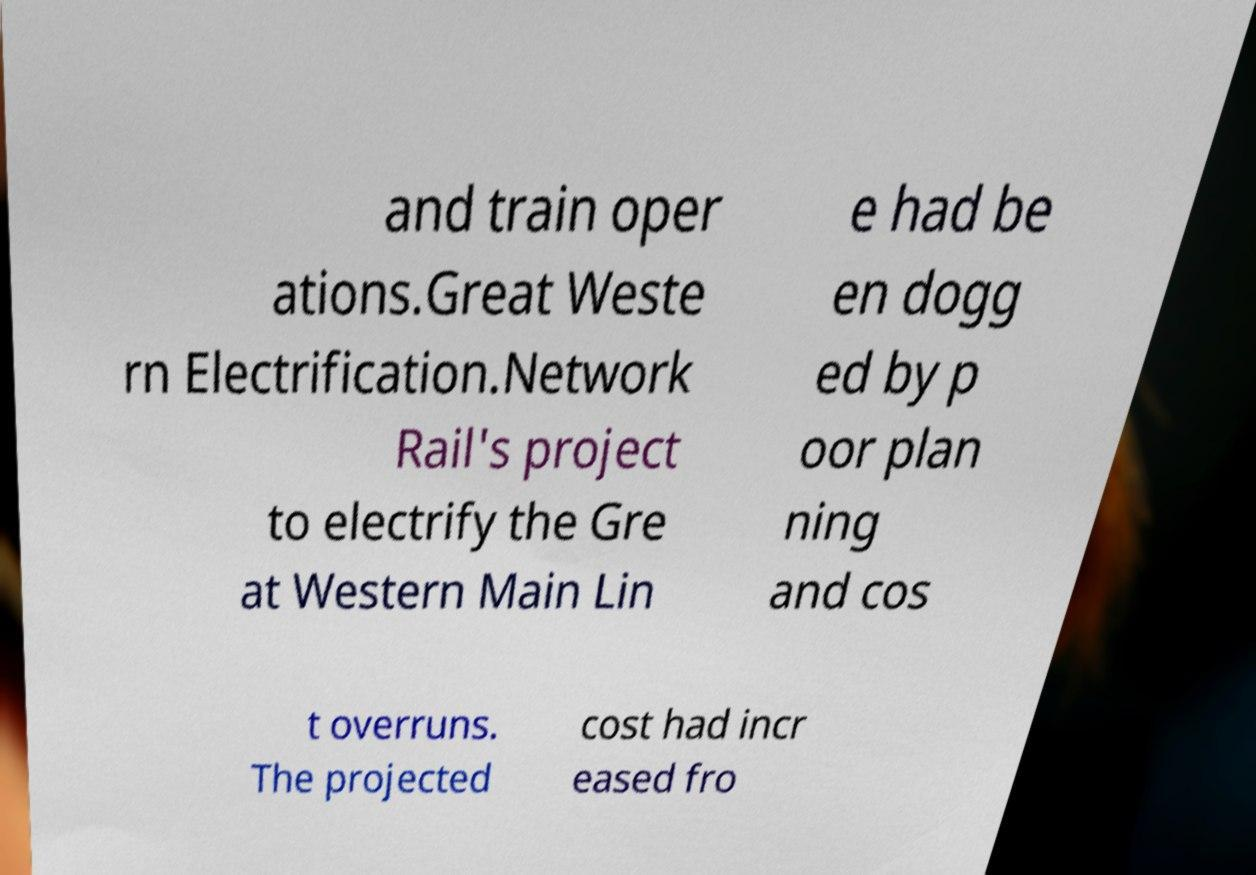Please read and relay the text visible in this image. What does it say? and train oper ations.Great Weste rn Electrification.Network Rail's project to electrify the Gre at Western Main Lin e had be en dogg ed by p oor plan ning and cos t overruns. The projected cost had incr eased fro 